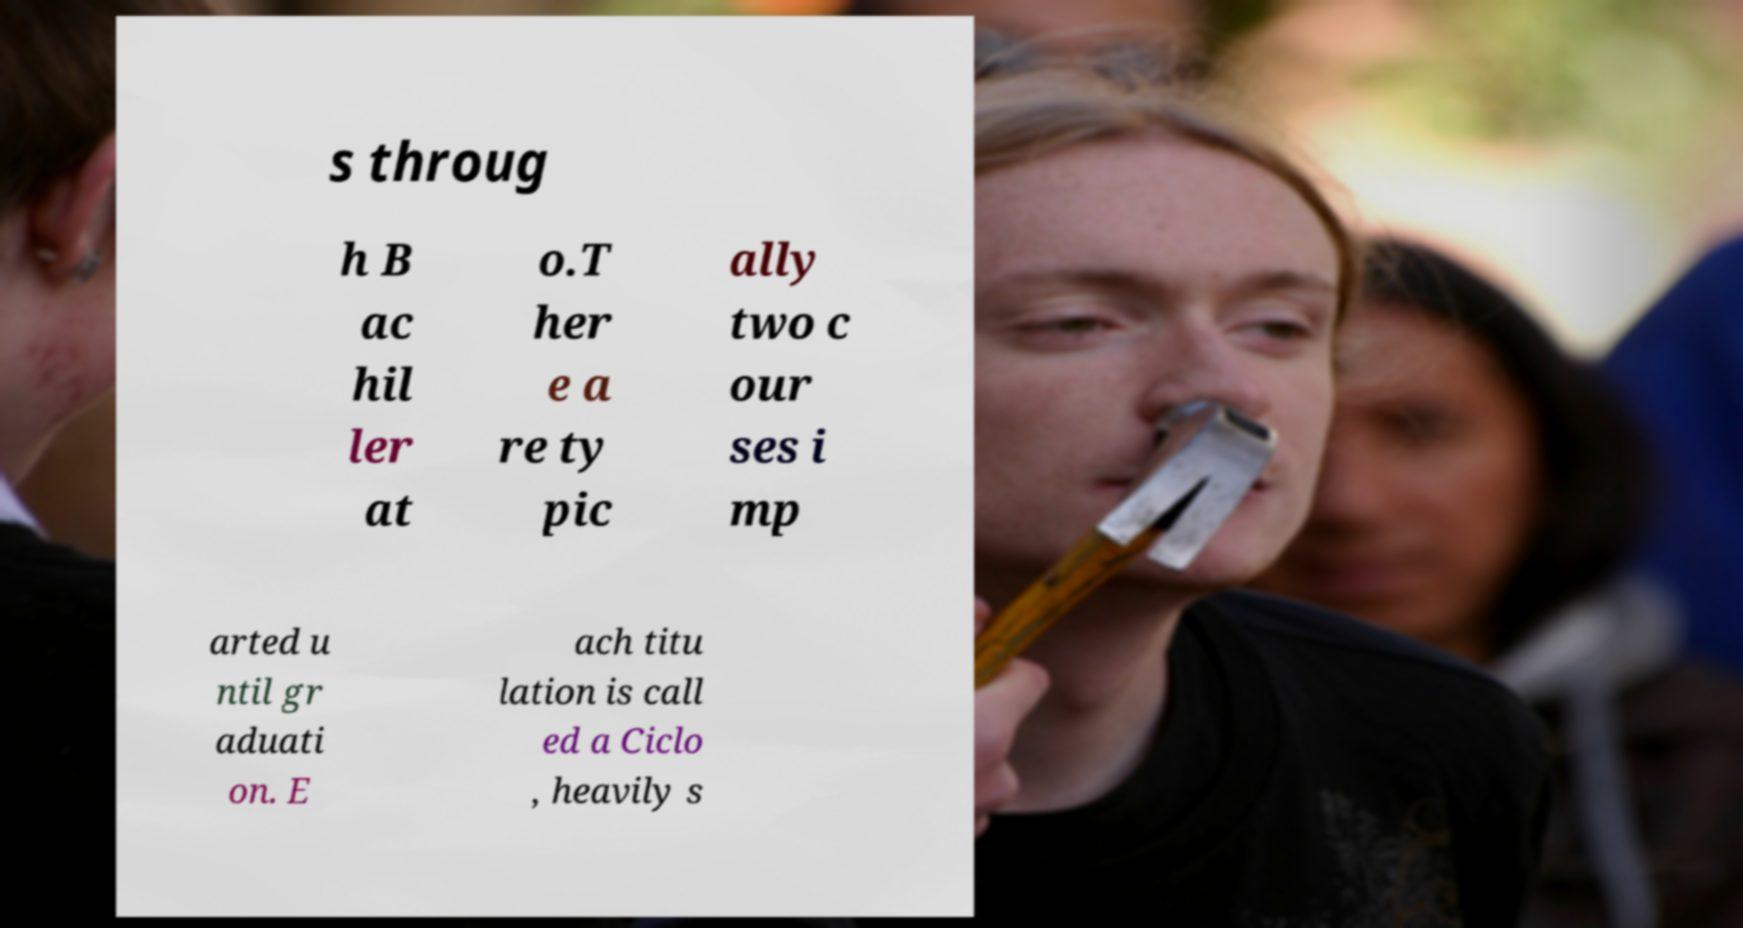Please read and relay the text visible in this image. What does it say? s throug h B ac hil ler at o.T her e a re ty pic ally two c our ses i mp arted u ntil gr aduati on. E ach titu lation is call ed a Ciclo , heavily s 